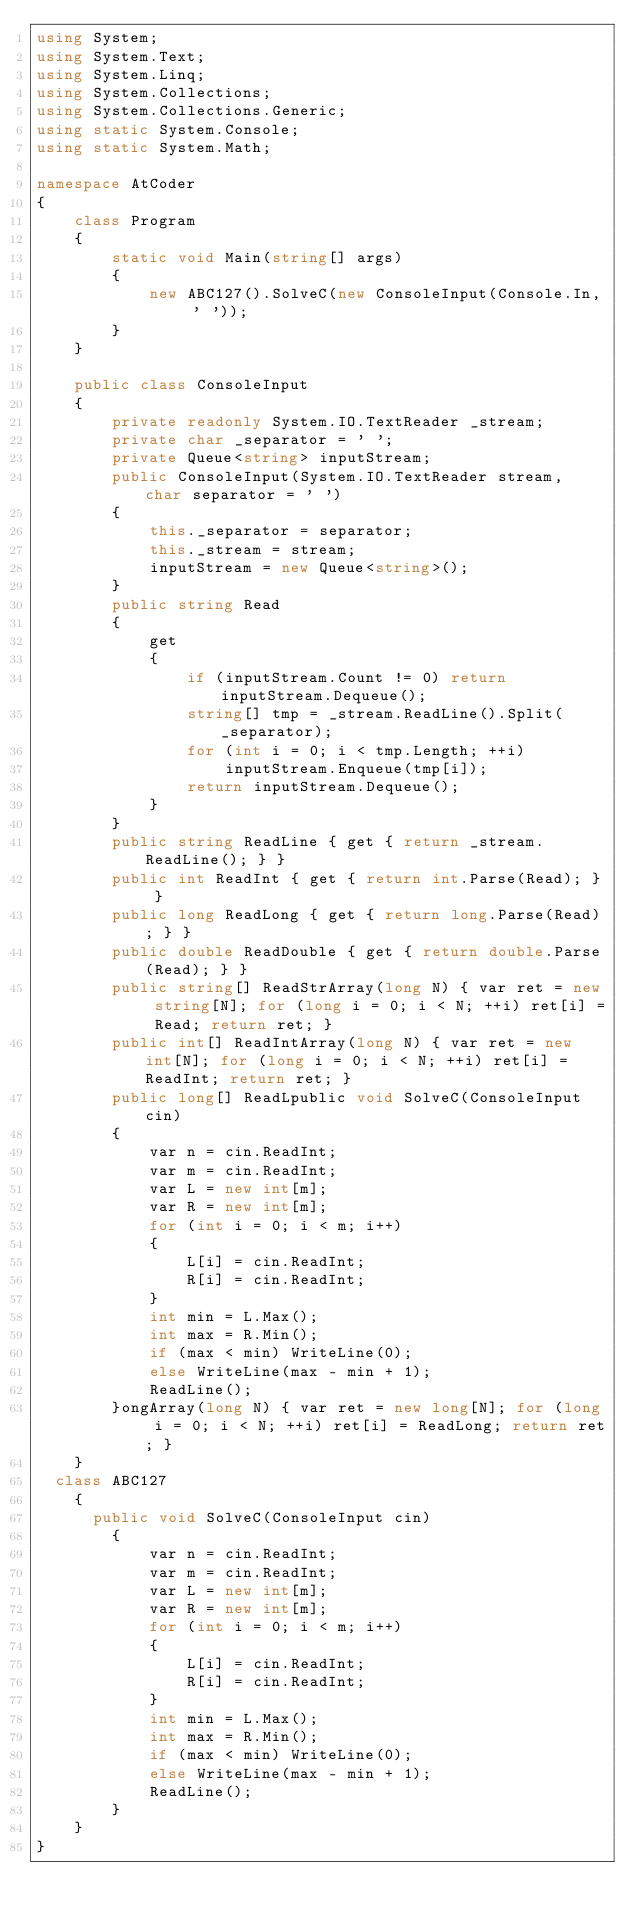<code> <loc_0><loc_0><loc_500><loc_500><_C#_>using System;
using System.Text;
using System.Linq;
using System.Collections;
using System.Collections.Generic;
using static System.Console;
using static System.Math;

namespace AtCoder
{
    class Program
    {
        static void Main(string[] args)
        {
            new ABC127().SolveC(new ConsoleInput(Console.In, ' '));
        }
    }

    public class ConsoleInput
    {
        private readonly System.IO.TextReader _stream;
        private char _separator = ' ';
        private Queue<string> inputStream;
        public ConsoleInput(System.IO.TextReader stream, char separator = ' ')
        {
            this._separator = separator;
            this._stream = stream;
            inputStream = new Queue<string>();
        }
        public string Read
        {
            get
            {
                if (inputStream.Count != 0) return inputStream.Dequeue();
                string[] tmp = _stream.ReadLine().Split(_separator);
                for (int i = 0; i < tmp.Length; ++i)
                    inputStream.Enqueue(tmp[i]);
                return inputStream.Dequeue();
            }
        }
        public string ReadLine { get { return _stream.ReadLine(); } }
        public int ReadInt { get { return int.Parse(Read); } }
        public long ReadLong { get { return long.Parse(Read); } }
        public double ReadDouble { get { return double.Parse(Read); } }
        public string[] ReadStrArray(long N) { var ret = new string[N]; for (long i = 0; i < N; ++i) ret[i] = Read; return ret; }
        public int[] ReadIntArray(long N) { var ret = new int[N]; for (long i = 0; i < N; ++i) ret[i] = ReadInt; return ret; }
        public long[] ReadLpublic void SolveC(ConsoleInput cin)
        {
            var n = cin.ReadInt;
            var m = cin.ReadInt;
            var L = new int[m];
            var R = new int[m];
            for (int i = 0; i < m; i++)
            {
                L[i] = cin.ReadInt;
                R[i] = cin.ReadInt;
            }
            int min = L.Max();
            int max = R.Min();
            if (max < min) WriteLine(0);
            else WriteLine(max - min + 1);
            ReadLine();
        }ongArray(long N) { var ret = new long[N]; for (long i = 0; i < N; ++i) ret[i] = ReadLong; return ret; }
    }
  class ABC127
    {
    	public void SolveC(ConsoleInput cin)
        {
            var n = cin.ReadInt;
            var m = cin.ReadInt;
            var L = new int[m];
            var R = new int[m];
            for (int i = 0; i < m; i++)
            {
                L[i] = cin.ReadInt;
                R[i] = cin.ReadInt;
            }
            int min = L.Max();
            int max = R.Min();
            if (max < min) WriteLine(0);
            else WriteLine(max - min + 1);
            ReadLine();
        }
    }
}
</code> 